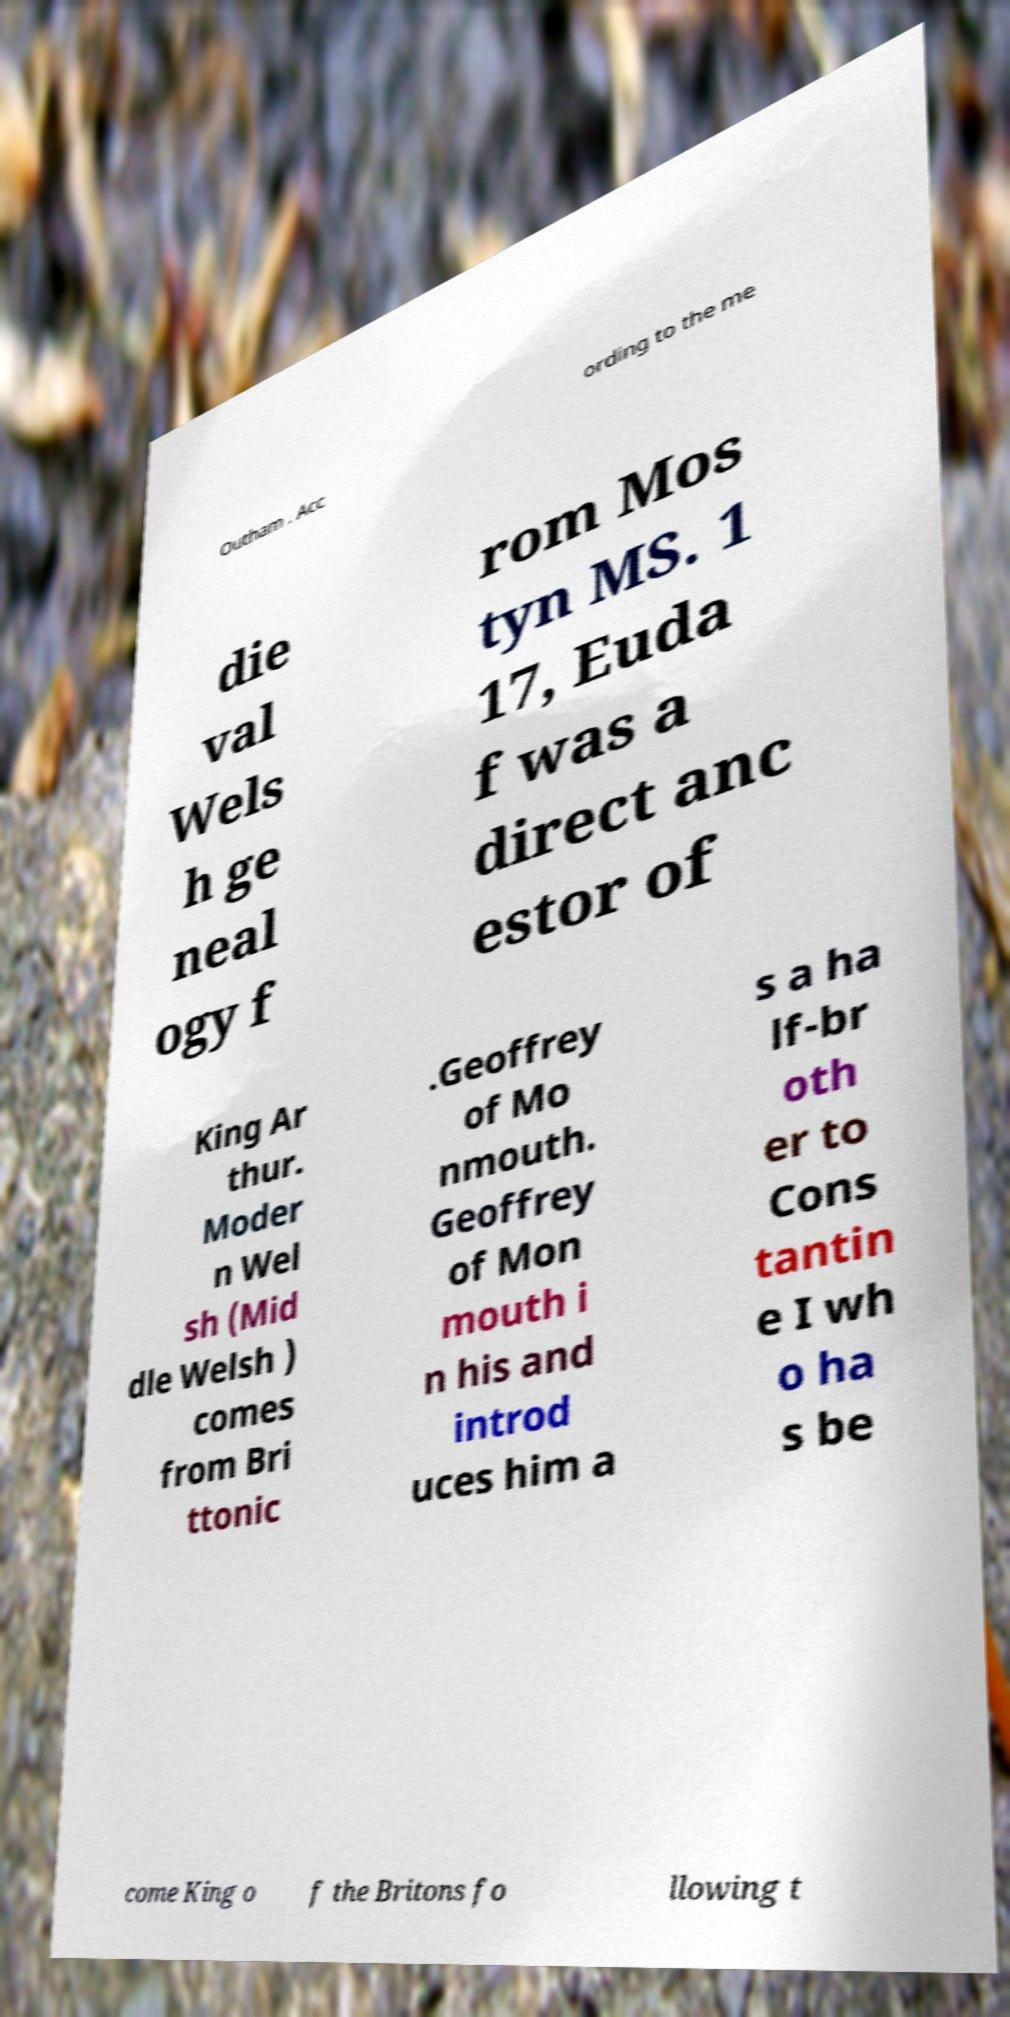Could you extract and type out the text from this image? Outham . Acc ording to the me die val Wels h ge neal ogy f rom Mos tyn MS. 1 17, Euda f was a direct anc estor of King Ar thur. Moder n Wel sh (Mid dle Welsh ) comes from Bri ttonic .Geoffrey of Mo nmouth. Geoffrey of Mon mouth i n his and introd uces him a s a ha lf-br oth er to Cons tantin e I wh o ha s be come King o f the Britons fo llowing t 